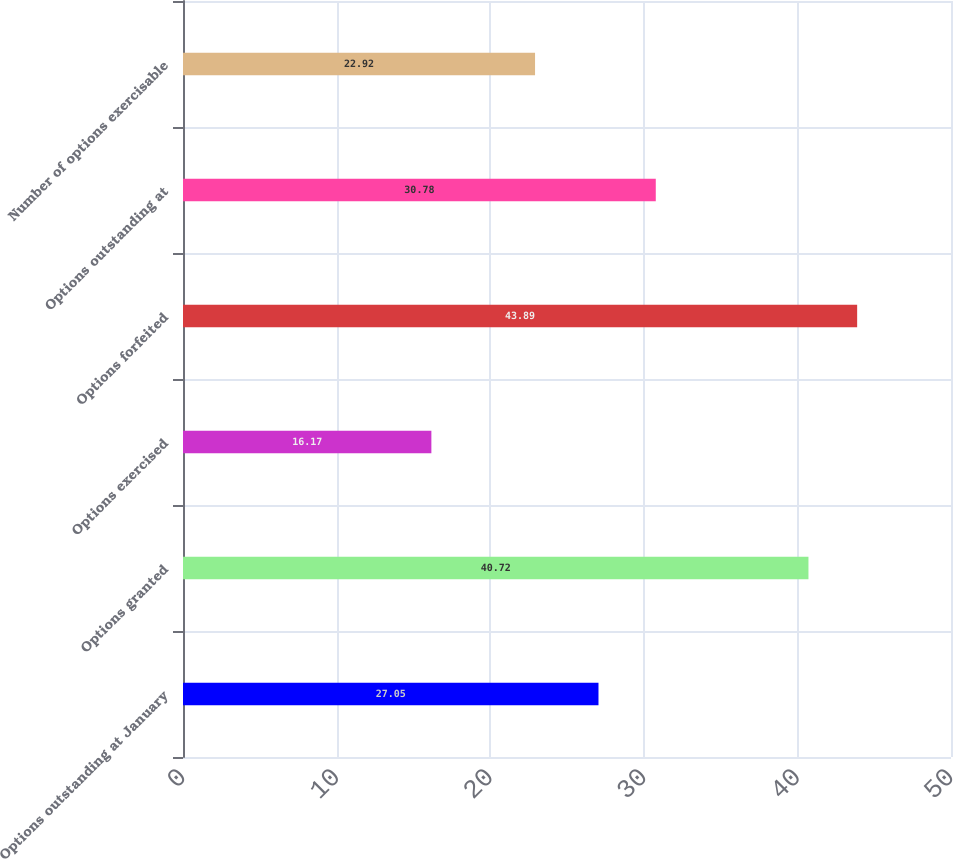<chart> <loc_0><loc_0><loc_500><loc_500><bar_chart><fcel>Options outstanding at January<fcel>Options granted<fcel>Options exercised<fcel>Options forfeited<fcel>Options outstanding at<fcel>Number of options exercisable<nl><fcel>27.05<fcel>40.72<fcel>16.17<fcel>43.89<fcel>30.78<fcel>22.92<nl></chart> 